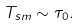<formula> <loc_0><loc_0><loc_500><loc_500>T _ { s m } \sim \tau _ { 0 } .</formula> 